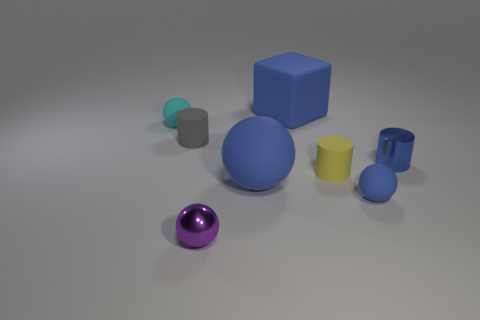Is the tiny metallic cylinder the same color as the block?
Keep it short and to the point. Yes. What number of matte things are large balls or blue objects?
Your answer should be compact. 3. The big rubber thing that is the same color as the large rubber ball is what shape?
Give a very brief answer. Cube. How many purple cylinders are there?
Your answer should be very brief. 0. Is the tiny blue thing that is in front of the metal cylinder made of the same material as the tiny blue object that is behind the tiny blue matte sphere?
Give a very brief answer. No. There is a yellow cylinder that is made of the same material as the small cyan ball; what size is it?
Your answer should be very brief. Small. There is a blue object that is on the left side of the blue cube; what shape is it?
Keep it short and to the point. Sphere. There is a metallic object that is to the right of the large blue ball; does it have the same color as the big thing that is behind the small cyan rubber ball?
Keep it short and to the point. Yes. The metal cylinder that is the same color as the large rubber sphere is what size?
Your answer should be very brief. Small. Is there a small cyan rubber object?
Offer a very short reply. Yes. 